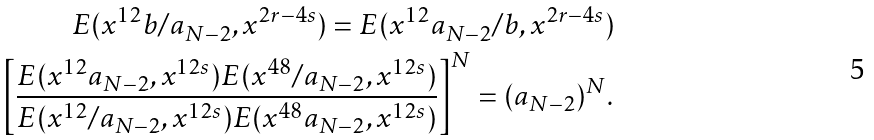<formula> <loc_0><loc_0><loc_500><loc_500>E ( x ^ { 1 2 } b / a _ { N - 2 } , x ^ { 2 r - 4 s } ) = E ( x ^ { 1 2 } a _ { N - 2 } / b , x ^ { 2 r - 4 s } ) \\ \left [ \frac { E ( x ^ { 1 2 } a _ { N - 2 } , x ^ { 1 2 s } ) E ( x ^ { 4 8 } / a _ { N - 2 } , x ^ { 1 2 s } ) } { E ( x ^ { 1 2 } / a _ { N - 2 } , x ^ { 1 2 s } ) E ( x ^ { 4 8 } a _ { N - 2 } , x ^ { 1 2 s } ) } \right ] ^ { N } = ( a _ { N - 2 } ) ^ { N } .</formula> 